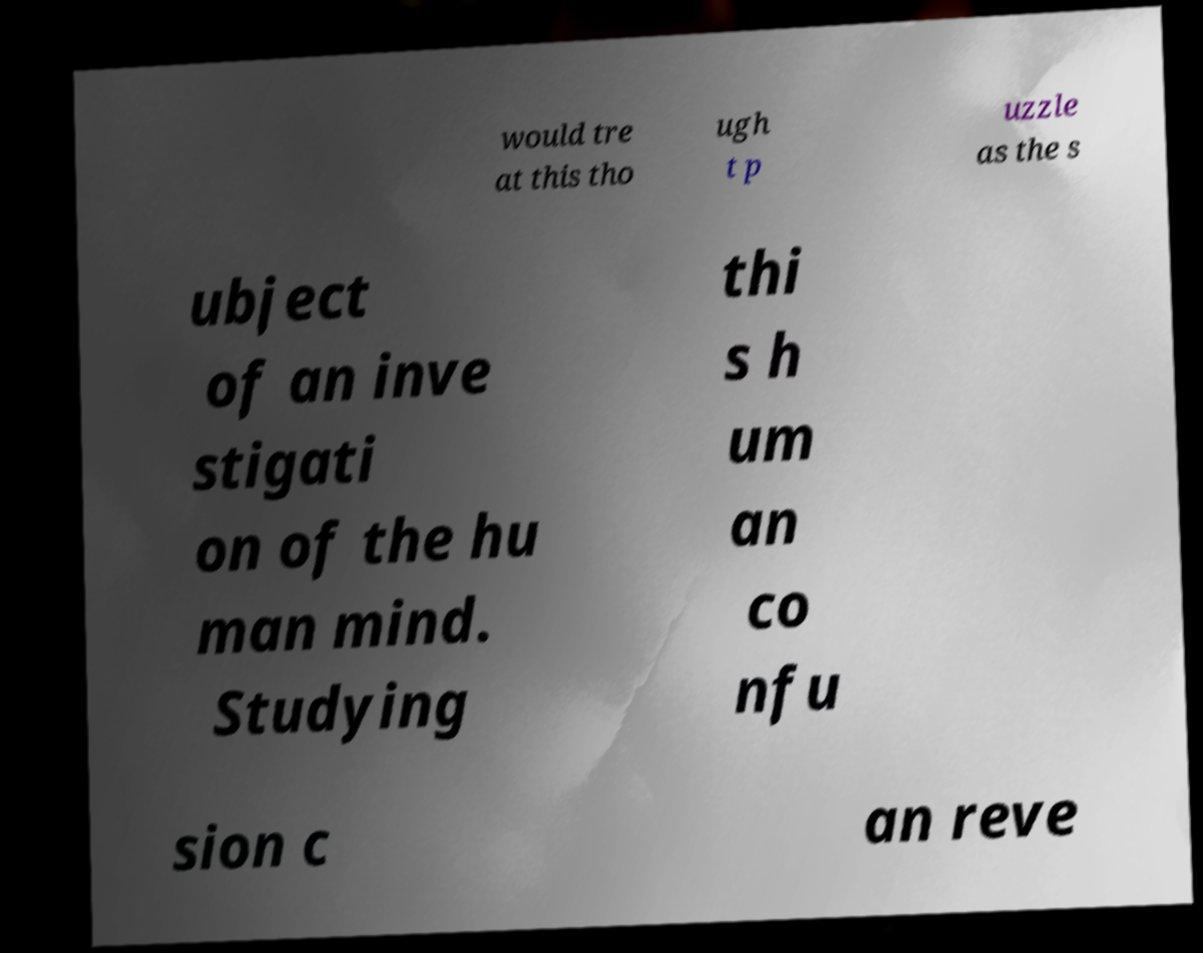Can you accurately transcribe the text from the provided image for me? would tre at this tho ugh t p uzzle as the s ubject of an inve stigati on of the hu man mind. Studying thi s h um an co nfu sion c an reve 